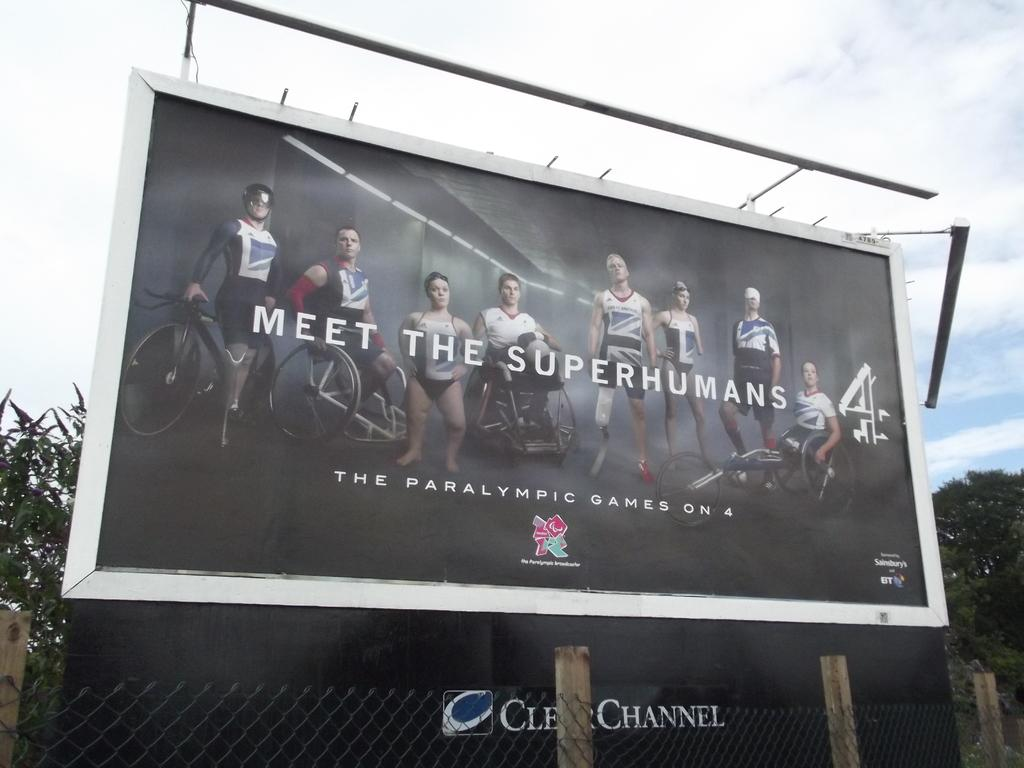<image>
Summarize the visual content of the image. A billboard promoting the show Meet The Superhumans 